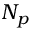Convert formula to latex. <formula><loc_0><loc_0><loc_500><loc_500>N _ { p }</formula> 